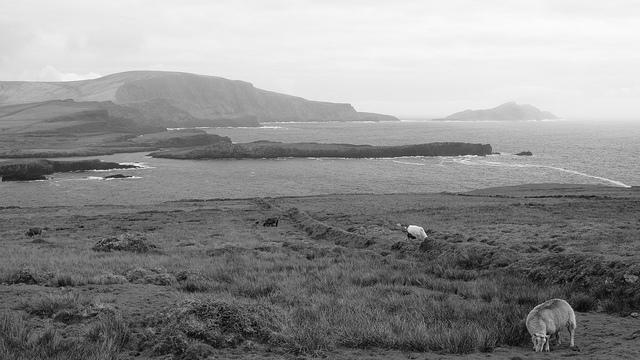Is this picture in a field?
Concise answer only. Yes. How many animals in the picture?
Write a very short answer. 2. Is this a calming picture?
Be succinct. Yes. What is the body of water behind the sheep called?
Write a very short answer. Ocean. Are the sheep walking in front of the vehicle?
Be succinct. No. What color is the dog?
Give a very brief answer. White. Is the picture in black and white?
Give a very brief answer. Yes. 